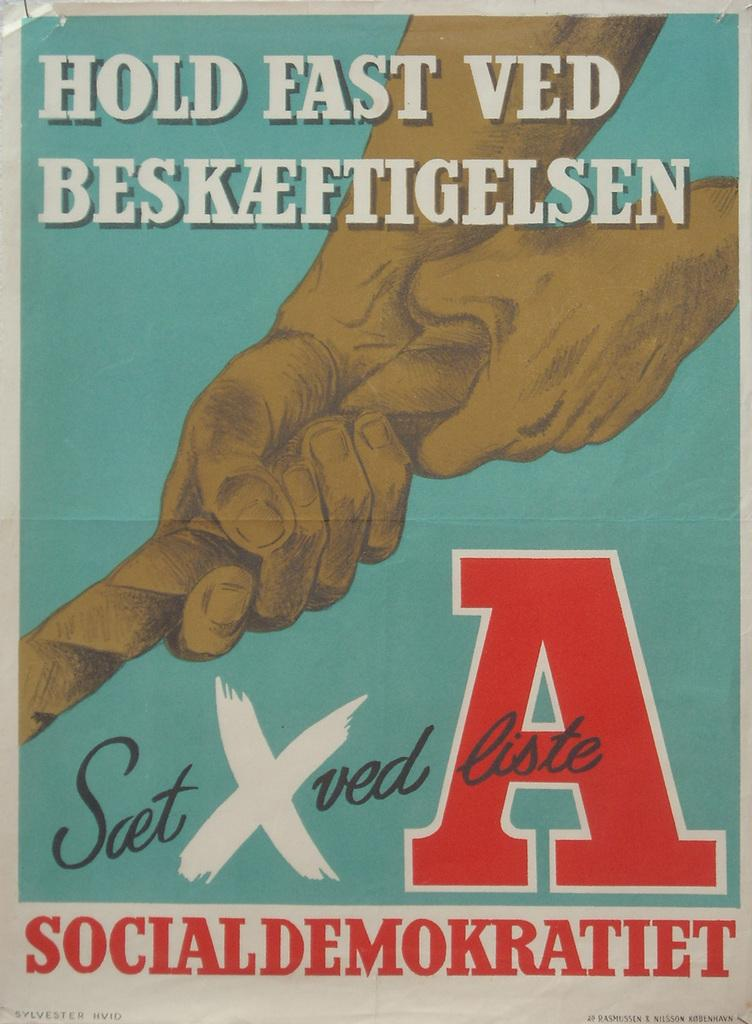Provide a one-sentence caption for the provided image. a poster saying "Hold Fast Ved" with hands pulling a rope. 